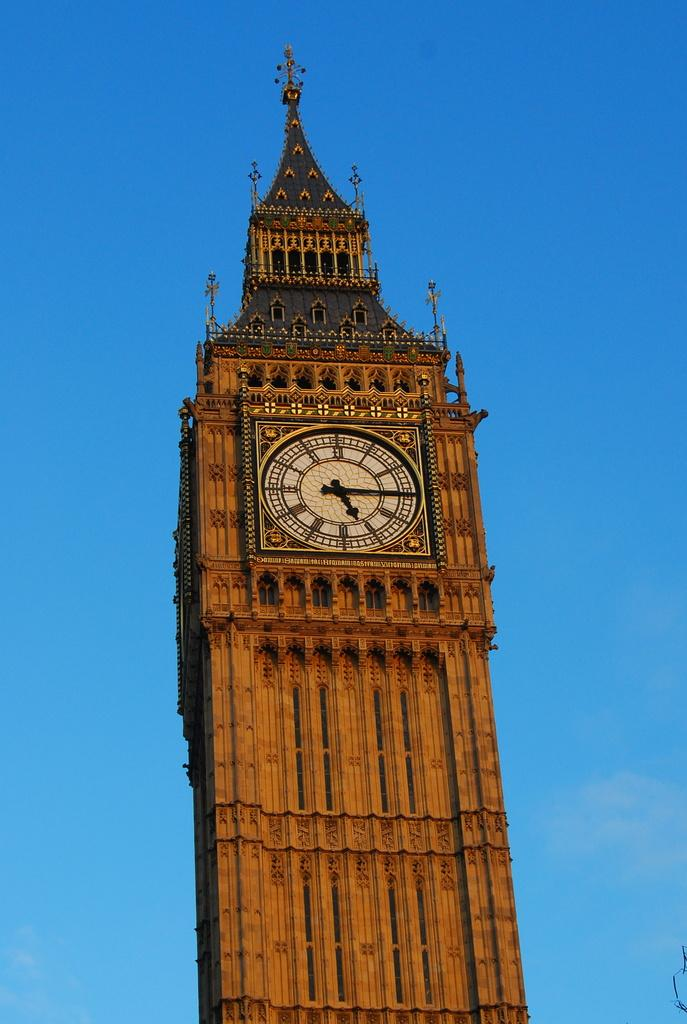What is the main subject of the image? The main subject of the image is a historical clock tower. What can be observed about the clock tower's design? The clock tower has architectural features. What function does the clock tower serve? The clock tower has a clock on it. What is the color of the sky behind the clock tower? The sky behind the clock tower is blue in color. Can you tell me how many goldfish are swimming around the clock tower in the image? There are no goldfish present in the image; it features a historical clock tower with a blue sky in the background. 